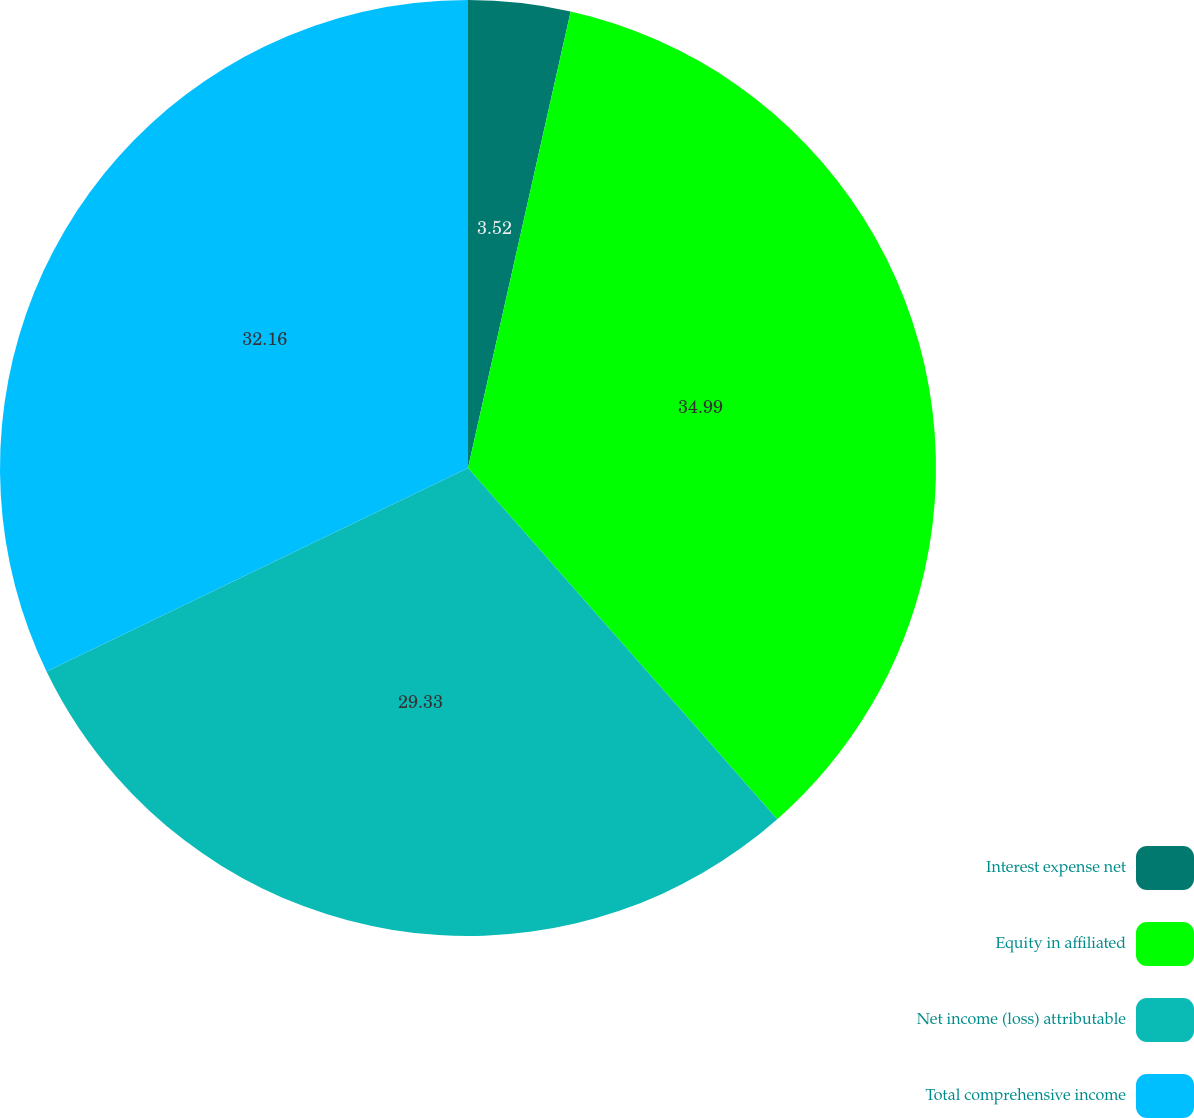Convert chart. <chart><loc_0><loc_0><loc_500><loc_500><pie_chart><fcel>Interest expense net<fcel>Equity in affiliated<fcel>Net income (loss) attributable<fcel>Total comprehensive income<nl><fcel>3.52%<fcel>34.99%<fcel>29.33%<fcel>32.16%<nl></chart> 